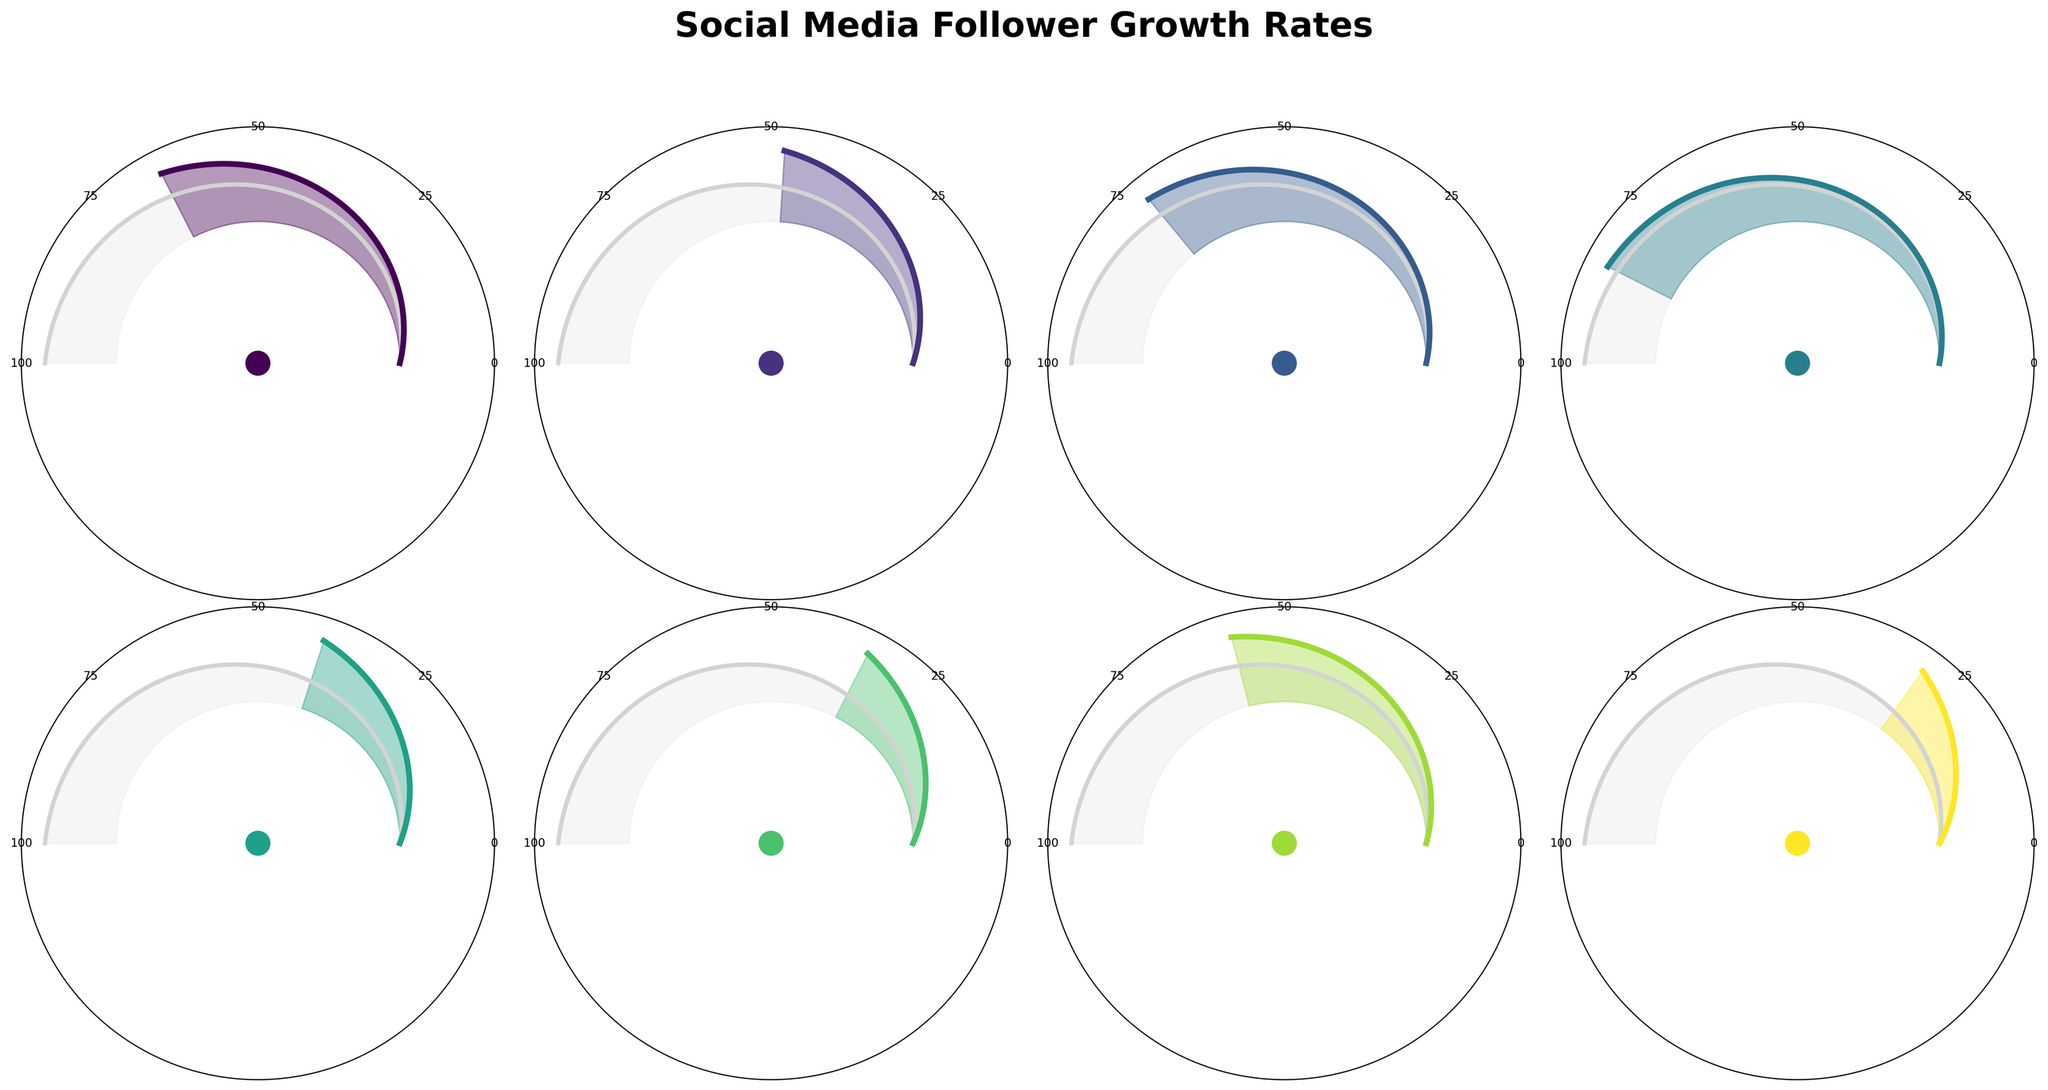What is the follower growth rate for TikTok? TikTok's growth rate can be directly read from the figure, as it's labeled within its gauge chart section. The text near TikTok's gauge shows an 85% growth rate.
Answer: 85% Which platform has the lowest growth rate? By inspecting each gauge chart, we observe that Facebook has the lowest labeled growth rate at 30%, which is the smallest on the figure.
Answer: Facebook How many platforms have a growth rate higher than 60%? We need to identify and count the platforms with growth rates higher than 60%. By looking at the gauges, they are Twitch (65%), YouTube (72%), TikTok (85%), and Instagram (58% isn't higher than 60%), so there are 3 platforms.
Answer: 3 What is the difference in growth rates between YouTube and Instagram? The growth rates for YouTube and Instagram are 72% and 58% respectively. The difference is calculated as 72% - 58% = 14%.
Answer: 14% Which platform shows the highest growth rate? By comparing the labeled growth rates on each gauge chart, TikTok has the highest growth rate at 85%.
Answer: TikTok Are there any platforms with exactly 50% growth rate? To determine if any platform has a 50% growth rate, we need to review each labeled percentage. None of the platforms listed have exactly a 50% growth rate.
Answer: No What is the average growth rate of all the platforms? The growth rates provided are 65, 48, 72, 85, 40, 35, 58, and 30. Sum these values to get 433. Dividing by the number of platforms (8) gives an average of 433/8 = 54.125%.
Answer: 54.125% Which platforms have a growth rate between 30% and 50% inclusive? The platforms in this range are SoundCloud (48%), Mixcloud (40%), Bandcamp (35%), and Facebook (30%).
Answer: SoundCloud, Mixcloud, Bandcamp, Facebook How does Mixcloud's growth rate compare to SoundCloud's? According to the figure, Mixcloud's growth rate is 40% while SoundCloud's is 48%. Mixcloud's growth rate is less than SoundCloud's by 8%.
Answer: Mixcloud is 8% lower Compare the sum of the growth rates for Twitch and TikTok to the sum of the growth rates for SoundCloud and Mixcloud. Which is higher? First, calculate the sums: Twitch (65%) + TikTok (85%) = 150%; SoundCloud (48%) + Mixcloud (40%) = 88%. The sum for Twitch and TikTok is higher.
Answer: Twitch and TikTok 